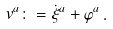Convert formula to latex. <formula><loc_0><loc_0><loc_500><loc_500>v ^ { a } & \colon = \dot { \xi } ^ { a } + \varphi ^ { a } \, .</formula> 